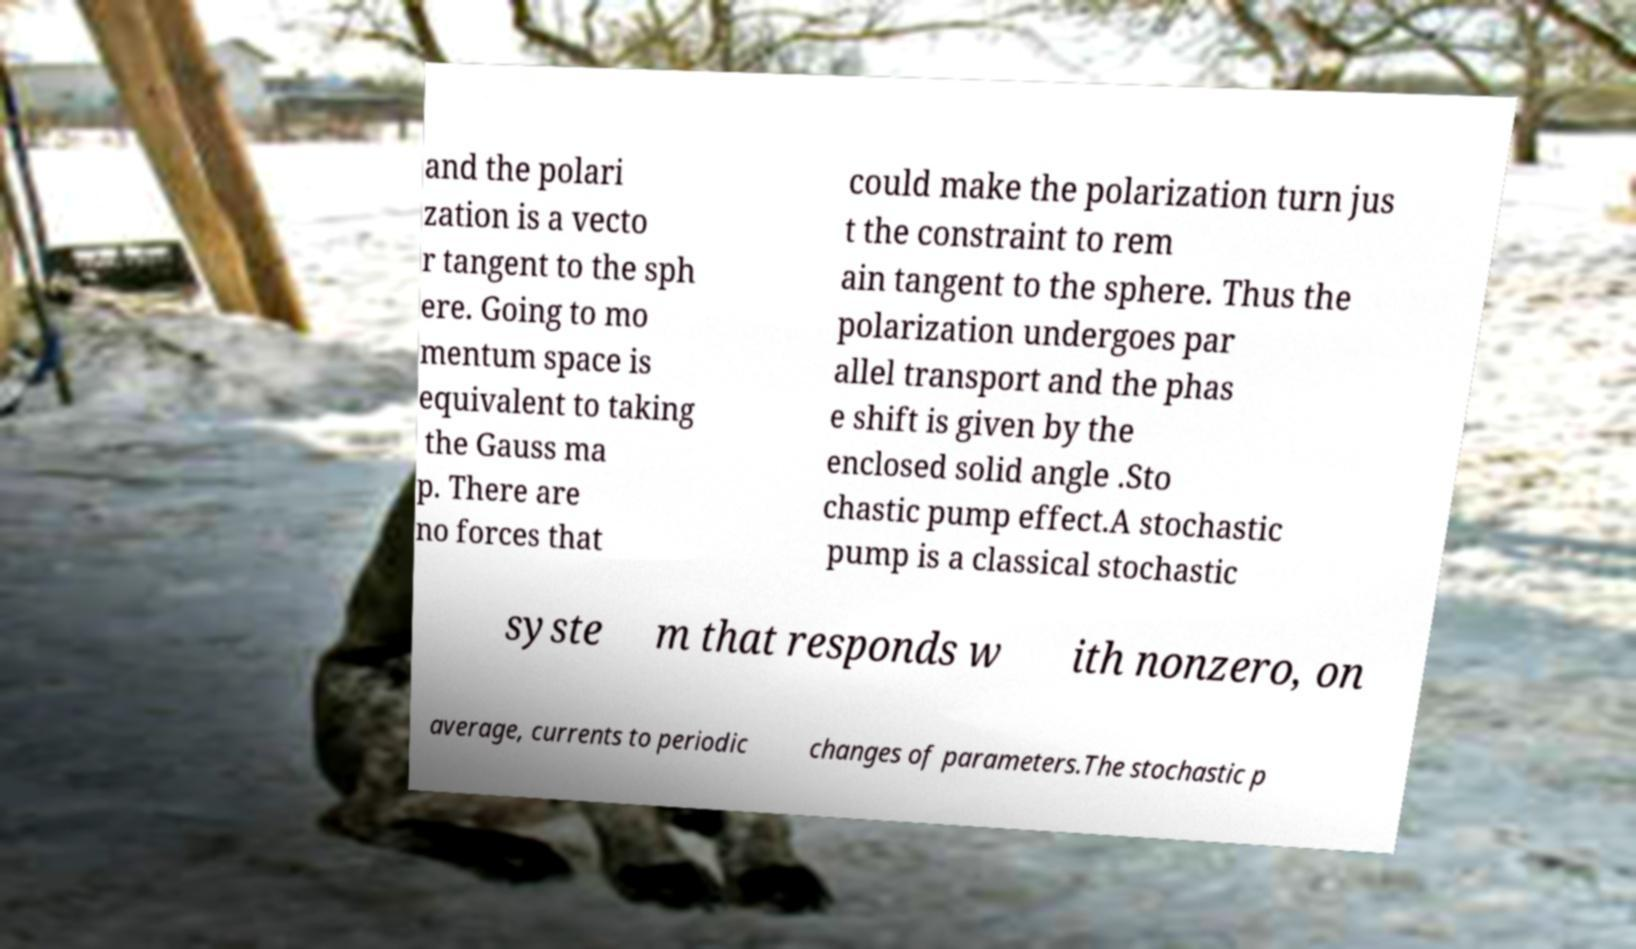What messages or text are displayed in this image? I need them in a readable, typed format. and the polari zation is a vecto r tangent to the sph ere. Going to mo mentum space is equivalent to taking the Gauss ma p. There are no forces that could make the polarization turn jus t the constraint to rem ain tangent to the sphere. Thus the polarization undergoes par allel transport and the phas e shift is given by the enclosed solid angle .Sto chastic pump effect.A stochastic pump is a classical stochastic syste m that responds w ith nonzero, on average, currents to periodic changes of parameters.The stochastic p 